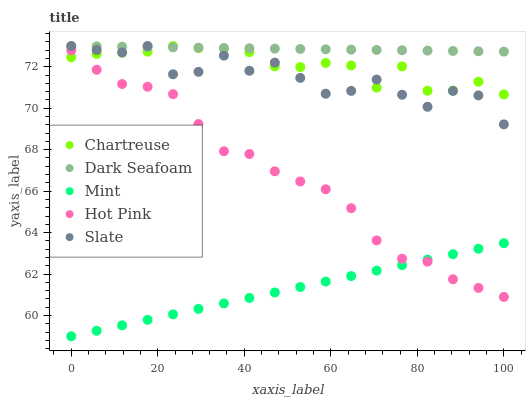Does Mint have the minimum area under the curve?
Answer yes or no. Yes. Does Dark Seafoam have the maximum area under the curve?
Answer yes or no. Yes. Does Chartreuse have the minimum area under the curve?
Answer yes or no. No. Does Chartreuse have the maximum area under the curve?
Answer yes or no. No. Is Mint the smoothest?
Answer yes or no. Yes. Is Slate the roughest?
Answer yes or no. Yes. Is Chartreuse the smoothest?
Answer yes or no. No. Is Chartreuse the roughest?
Answer yes or no. No. Does Mint have the lowest value?
Answer yes or no. Yes. Does Chartreuse have the lowest value?
Answer yes or no. No. Does Dark Seafoam have the highest value?
Answer yes or no. Yes. Does Hot Pink have the highest value?
Answer yes or no. No. Is Hot Pink less than Dark Seafoam?
Answer yes or no. Yes. Is Chartreuse greater than Mint?
Answer yes or no. Yes. Does Chartreuse intersect Hot Pink?
Answer yes or no. Yes. Is Chartreuse less than Hot Pink?
Answer yes or no. No. Is Chartreuse greater than Hot Pink?
Answer yes or no. No. Does Hot Pink intersect Dark Seafoam?
Answer yes or no. No. 